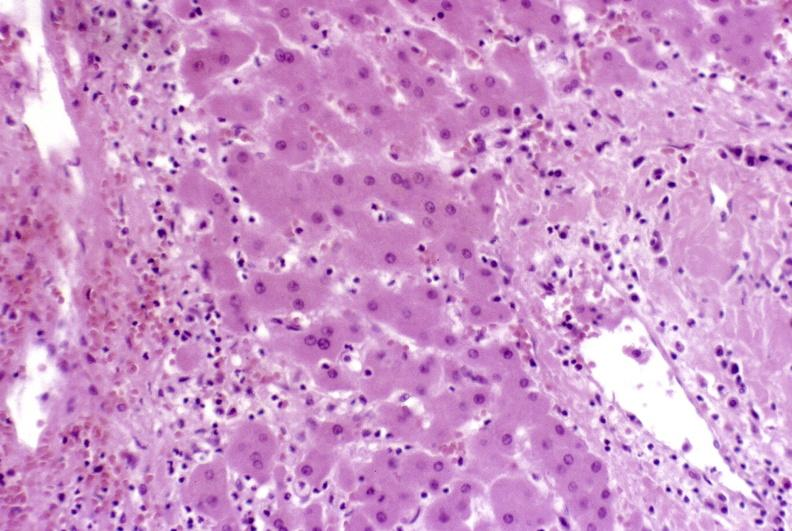s endometritis present?
Answer the question using a single word or phrase. No 